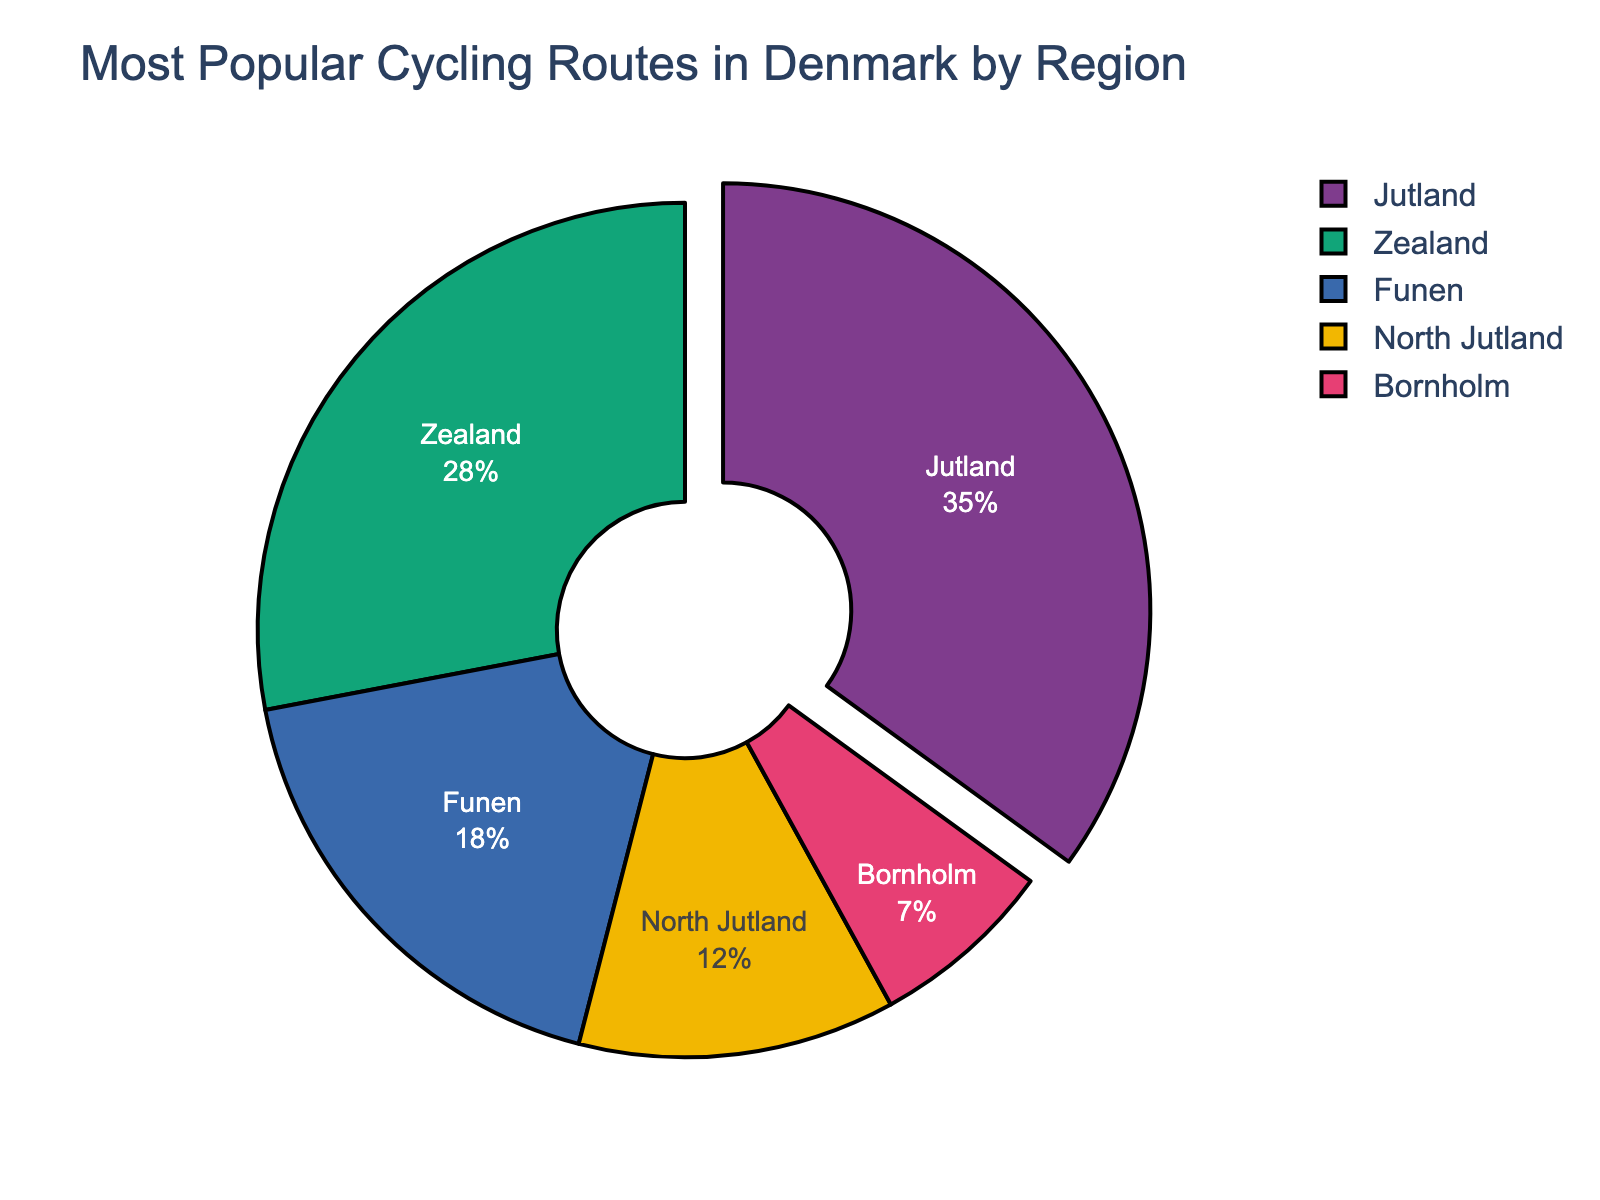Which region has the highest percentage of popular cycling routes? First, look for the region with the largest section in the pie chart. Jutland is the largest segment followed by others, so it has the highest percentage.
Answer: Jutland What is the combined percentage of popular cycling routes in Zealand and Funen? Sum the percentages of Zealand and Funen: 28% + 18% = 46%.
Answer: 46% How does the percentage of North Jutland compare to Bornholm? Compare the segments for North Jutland and Bornholm. North Jutland has 12% while Bornholm has 7%. North Jutland's percentage is higher.
Answer: North Jutland's percentage is higher What percentage of popular cycling routes do Zealand, Funen, and Bornholm collectively cover? Add the percentages of Zealand (28%), Funen (18%), and Bornholm (7%): 28% + 18% + 7% = 53%.
Answer: 53% Which region has a percentage closest to 20% for popular cycling routes? Look for the region whose percentage is nearest to 20%. Funen has 18%, which is the closest to 20%.
Answer: Funen Is the percentage of popular cycling routes in Jutland more than twice that in Zealand? Check if the percentage in Jutland (35%) is more than twice that in Zealand (28%). Calculation: 28 * 2 = 56, and 35 < 56, so it's not more than twice.
Answer: No What is the difference in percentage between Jutland and North Jutland? Subtract the percentage of North Jutland from Jutland: 35% - 12% = 23%.
Answer: 23% If regions with less than 10% popularity were combined into one category, what would their combined percentage be? Only Bornholm has less than 10%, so its percentage is the combined value: 7%.
Answer: 7% Which region is represented in blue in the pie chart? From the visual attributes of the pie chart colors, identify which segment is blue. This color represents Funen.
Answer: Funen 